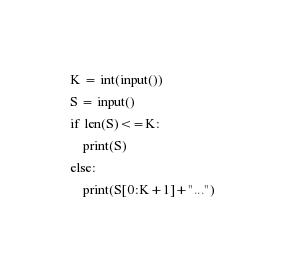<code> <loc_0><loc_0><loc_500><loc_500><_Python_>K = int(input())
S = input()
if len(S)<=K:
    print(S)
else:
    print(S[0:K+1]+"...")</code> 